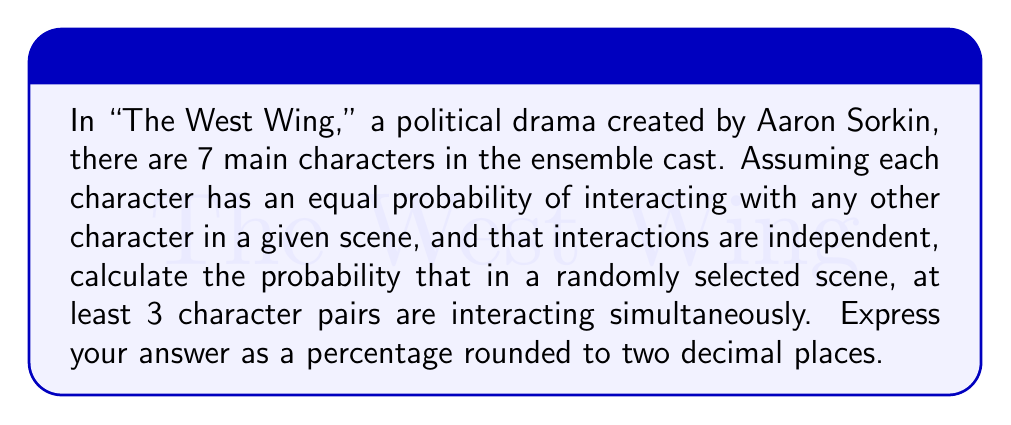Teach me how to tackle this problem. To solve this problem, we'll use network theory and probability concepts. Let's break it down step-by-step:

1) First, we need to calculate the total number of possible character pairs. With 7 characters, we can use the combination formula:

   $$\binom{7}{2} = \frac{7!}{2!(7-2)!} = \frac{7 \cdot 6}{2} = 21$$

   So there are 21 possible character pairs.

2) Now, we need to calculate the probability of at least 3 pairs interacting. It's easier to calculate the probability of 0, 1, or 2 pairs interacting and subtract from 1.

3) Let's use $p$ to represent the probability of a pair interacting in a scene. Since each interaction is independent and equally likely, we can use the binomial distribution.

4) The probability of exactly $k$ pairs interacting is:

   $$P(X = k) = \binom{21}{k} p^k (1-p)^{21-k}$$

5) We don't know $p$, but we can assume it's relatively small, say 0.1 (10% chance for any given pair to interact in a scene).

6) Now let's calculate the probabilities:

   For 0 pairs: $$P(X = 0) = \binom{21}{0} (0.1)^0 (0.9)^{21} = 0.1052$$
   
   For 1 pair: $$P(X = 1) = \binom{21}{1} (0.1)^1 (0.9)^{20} = 0.2457$$
   
   For 2 pairs: $$P(X = 2) = \binom{21}{2} (0.1)^2 (0.9)^{19} = 0.2731$$

7) The probability of 0, 1, or 2 pairs interacting is the sum of these:

   $$0.1052 + 0.2457 + 0.2731 = 0.6240$$

8) Therefore, the probability of at least 3 pairs interacting is:

   $$1 - 0.6240 = 0.3760$$

9) Converting to a percentage and rounding to two decimal places:

   $$0.3760 \times 100 = 37.60\%$$
Answer: 37.60% 